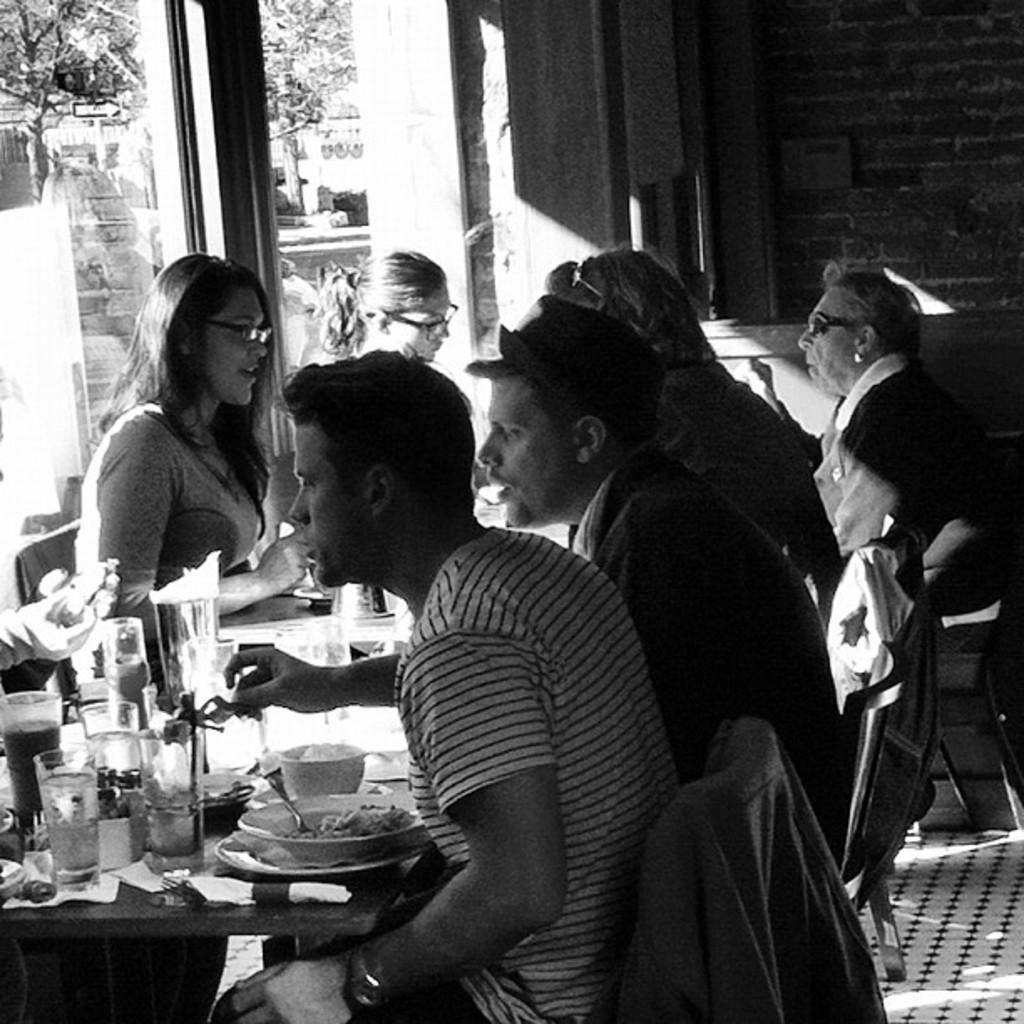What are the people in the image doing? The people in the image are sitting on chairs. What is present on the table in the image? There is a table in the image, and on it, there is a bowl containing food items and a juice glass. What is the color scheme of the image? The image is in black and white color. Where is the goose located in the image? There is no goose present in the image. What type of vest is being worn by the people in the image? The image is in black and white color, and there is no indication of clothing, including vests, on the people in the image. 